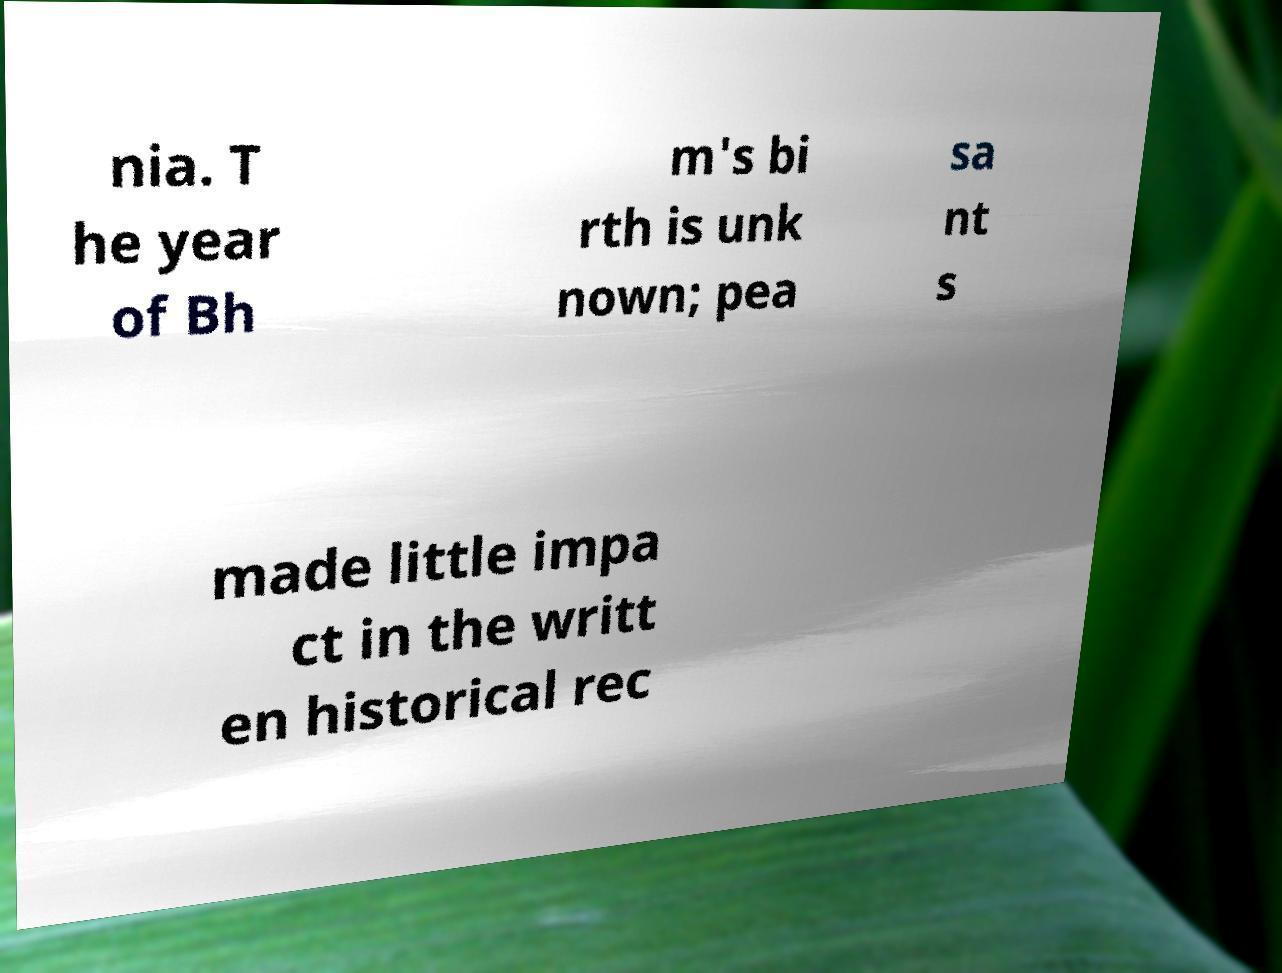Could you assist in decoding the text presented in this image and type it out clearly? nia. T he year of Bh m's bi rth is unk nown; pea sa nt s made little impa ct in the writt en historical rec 